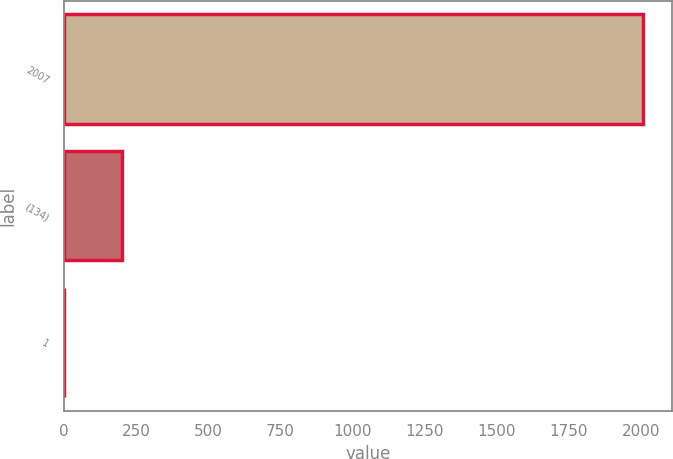Convert chart to OTSL. <chart><loc_0><loc_0><loc_500><loc_500><bar_chart><fcel>2007<fcel>(134)<fcel>1<nl><fcel>2005<fcel>201.4<fcel>1<nl></chart> 